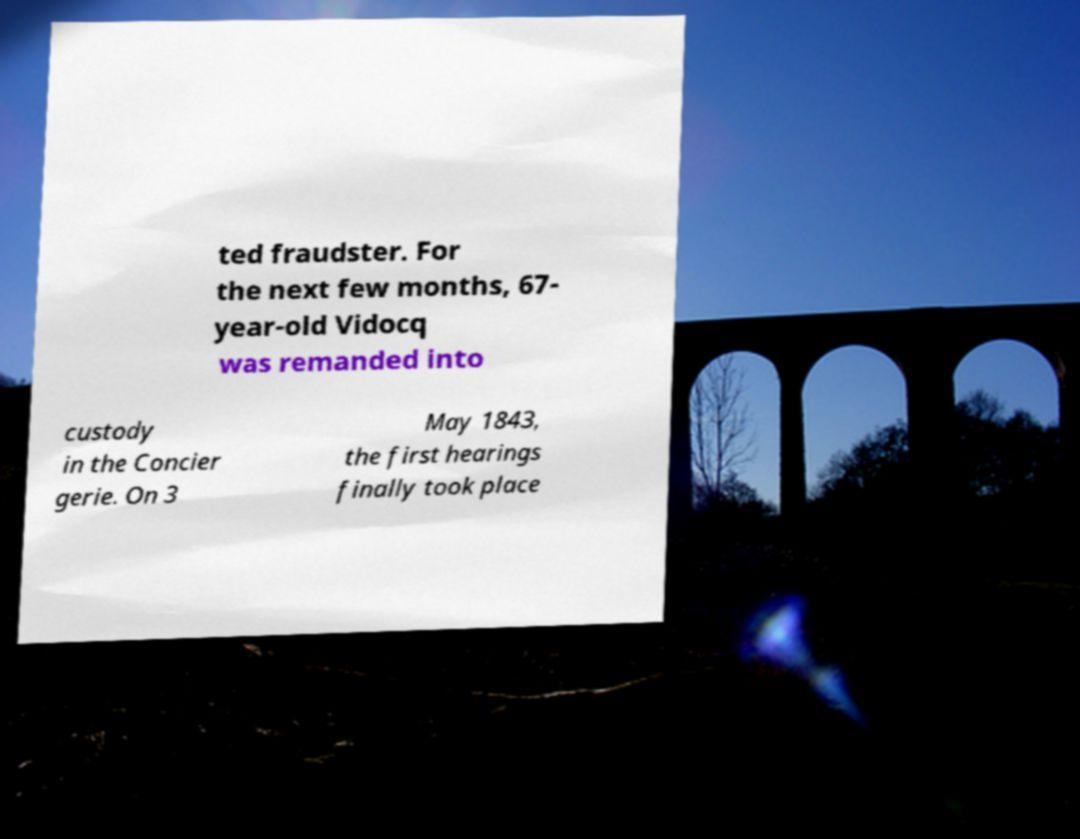Please read and relay the text visible in this image. What does it say? ted fraudster. For the next few months, 67- year-old Vidocq was remanded into custody in the Concier gerie. On 3 May 1843, the first hearings finally took place 